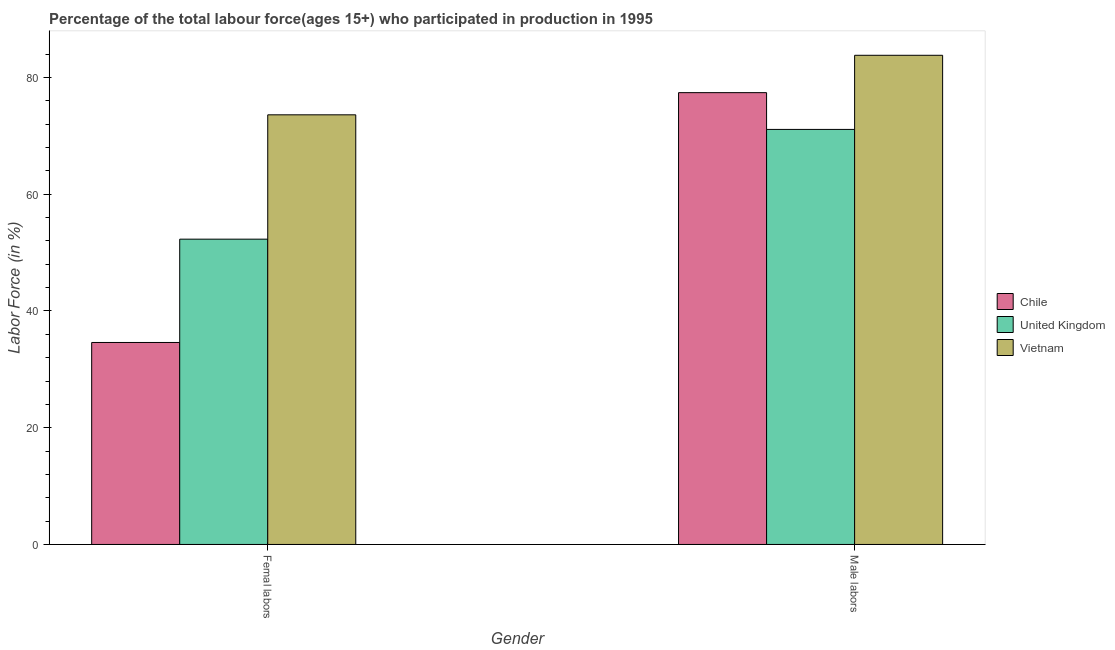How many different coloured bars are there?
Your answer should be very brief. 3. Are the number of bars per tick equal to the number of legend labels?
Provide a short and direct response. Yes. How many bars are there on the 1st tick from the left?
Offer a terse response. 3. How many bars are there on the 2nd tick from the right?
Your answer should be compact. 3. What is the label of the 2nd group of bars from the left?
Give a very brief answer. Male labors. What is the percentage of male labour force in United Kingdom?
Your answer should be very brief. 71.1. Across all countries, what is the maximum percentage of female labor force?
Your answer should be compact. 73.6. Across all countries, what is the minimum percentage of male labour force?
Offer a very short reply. 71.1. In which country was the percentage of female labor force maximum?
Provide a short and direct response. Vietnam. What is the total percentage of female labor force in the graph?
Your response must be concise. 160.5. What is the difference between the percentage of male labour force in Chile and that in United Kingdom?
Keep it short and to the point. 6.3. What is the difference between the percentage of female labor force in Chile and the percentage of male labour force in Vietnam?
Offer a very short reply. -49.2. What is the average percentage of female labor force per country?
Offer a terse response. 53.5. What is the difference between the percentage of male labour force and percentage of female labor force in Chile?
Provide a short and direct response. 42.8. What is the ratio of the percentage of male labour force in Chile to that in Vietnam?
Provide a short and direct response. 0.92. Is the percentage of female labor force in United Kingdom less than that in Vietnam?
Provide a succinct answer. Yes. What does the 3rd bar from the left in Femal labors represents?
Offer a very short reply. Vietnam. How many bars are there?
Ensure brevity in your answer.  6. What is the difference between two consecutive major ticks on the Y-axis?
Provide a succinct answer. 20. Are the values on the major ticks of Y-axis written in scientific E-notation?
Your answer should be compact. No. How are the legend labels stacked?
Your answer should be compact. Vertical. What is the title of the graph?
Offer a terse response. Percentage of the total labour force(ages 15+) who participated in production in 1995. What is the label or title of the X-axis?
Your answer should be very brief. Gender. What is the label or title of the Y-axis?
Your answer should be very brief. Labor Force (in %). What is the Labor Force (in %) in Chile in Femal labors?
Your answer should be compact. 34.6. What is the Labor Force (in %) of United Kingdom in Femal labors?
Your response must be concise. 52.3. What is the Labor Force (in %) of Vietnam in Femal labors?
Your response must be concise. 73.6. What is the Labor Force (in %) of Chile in Male labors?
Offer a very short reply. 77.4. What is the Labor Force (in %) of United Kingdom in Male labors?
Provide a short and direct response. 71.1. What is the Labor Force (in %) in Vietnam in Male labors?
Your response must be concise. 83.8. Across all Gender, what is the maximum Labor Force (in %) in Chile?
Offer a terse response. 77.4. Across all Gender, what is the maximum Labor Force (in %) of United Kingdom?
Provide a short and direct response. 71.1. Across all Gender, what is the maximum Labor Force (in %) of Vietnam?
Provide a short and direct response. 83.8. Across all Gender, what is the minimum Labor Force (in %) of Chile?
Keep it short and to the point. 34.6. Across all Gender, what is the minimum Labor Force (in %) in United Kingdom?
Your answer should be very brief. 52.3. Across all Gender, what is the minimum Labor Force (in %) of Vietnam?
Keep it short and to the point. 73.6. What is the total Labor Force (in %) of Chile in the graph?
Your response must be concise. 112. What is the total Labor Force (in %) of United Kingdom in the graph?
Offer a very short reply. 123.4. What is the total Labor Force (in %) in Vietnam in the graph?
Keep it short and to the point. 157.4. What is the difference between the Labor Force (in %) of Chile in Femal labors and that in Male labors?
Offer a terse response. -42.8. What is the difference between the Labor Force (in %) of United Kingdom in Femal labors and that in Male labors?
Provide a succinct answer. -18.8. What is the difference between the Labor Force (in %) in Vietnam in Femal labors and that in Male labors?
Make the answer very short. -10.2. What is the difference between the Labor Force (in %) of Chile in Femal labors and the Labor Force (in %) of United Kingdom in Male labors?
Provide a short and direct response. -36.5. What is the difference between the Labor Force (in %) of Chile in Femal labors and the Labor Force (in %) of Vietnam in Male labors?
Keep it short and to the point. -49.2. What is the difference between the Labor Force (in %) of United Kingdom in Femal labors and the Labor Force (in %) of Vietnam in Male labors?
Provide a succinct answer. -31.5. What is the average Labor Force (in %) of United Kingdom per Gender?
Your answer should be compact. 61.7. What is the average Labor Force (in %) in Vietnam per Gender?
Your answer should be compact. 78.7. What is the difference between the Labor Force (in %) of Chile and Labor Force (in %) of United Kingdom in Femal labors?
Keep it short and to the point. -17.7. What is the difference between the Labor Force (in %) in Chile and Labor Force (in %) in Vietnam in Femal labors?
Make the answer very short. -39. What is the difference between the Labor Force (in %) of United Kingdom and Labor Force (in %) of Vietnam in Femal labors?
Provide a succinct answer. -21.3. What is the difference between the Labor Force (in %) in Chile and Labor Force (in %) in United Kingdom in Male labors?
Give a very brief answer. 6.3. What is the difference between the Labor Force (in %) of Chile and Labor Force (in %) of Vietnam in Male labors?
Your answer should be compact. -6.4. What is the ratio of the Labor Force (in %) of Chile in Femal labors to that in Male labors?
Your response must be concise. 0.45. What is the ratio of the Labor Force (in %) in United Kingdom in Femal labors to that in Male labors?
Offer a very short reply. 0.74. What is the ratio of the Labor Force (in %) of Vietnam in Femal labors to that in Male labors?
Your answer should be compact. 0.88. What is the difference between the highest and the second highest Labor Force (in %) in Chile?
Ensure brevity in your answer.  42.8. What is the difference between the highest and the second highest Labor Force (in %) in United Kingdom?
Your answer should be compact. 18.8. What is the difference between the highest and the second highest Labor Force (in %) in Vietnam?
Give a very brief answer. 10.2. What is the difference between the highest and the lowest Labor Force (in %) of Chile?
Provide a short and direct response. 42.8. What is the difference between the highest and the lowest Labor Force (in %) of United Kingdom?
Your response must be concise. 18.8. 